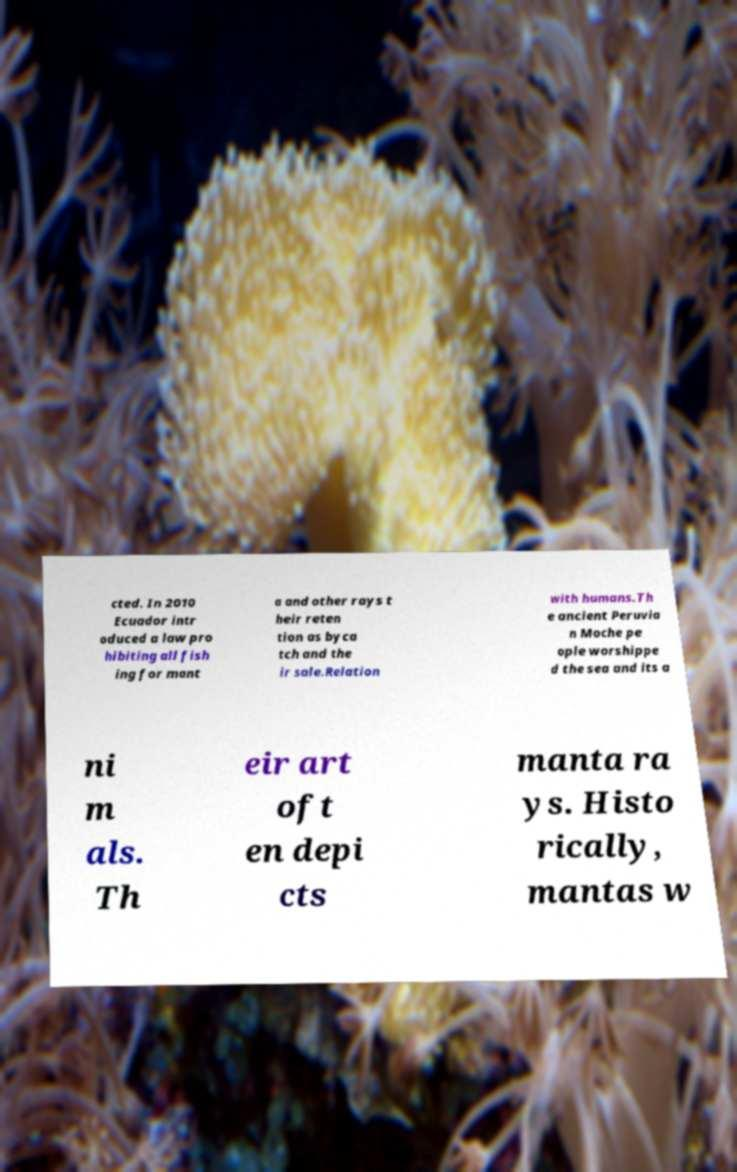Can you accurately transcribe the text from the provided image for me? cted. In 2010 Ecuador intr oduced a law pro hibiting all fish ing for mant a and other rays t heir reten tion as byca tch and the ir sale.Relation with humans.Th e ancient Peruvia n Moche pe ople worshippe d the sea and its a ni m als. Th eir art oft en depi cts manta ra ys. Histo rically, mantas w 